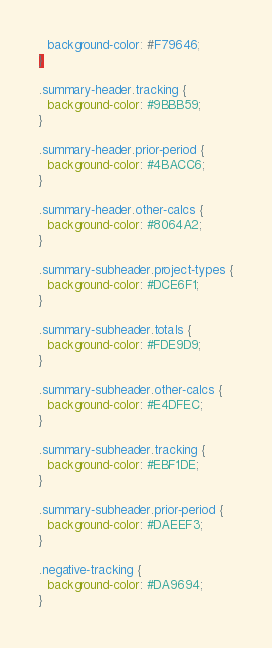<code> <loc_0><loc_0><loc_500><loc_500><_CSS_>  background-color: #F79646;
}

.summary-header.tracking {
  background-color: #9BBB59;
}

.summary-header.prior-period {
  background-color: #4BACC6;
}

.summary-header.other-calcs {
  background-color: #8064A2;
}

.summary-subheader.project-types {
  background-color: #DCE6F1;
}

.summary-subheader.totals {
  background-color: #FDE9D9;
}

.summary-subheader.other-calcs {
  background-color: #E4DFEC;
}

.summary-subheader.tracking {
  background-color: #EBF1DE;
}

.summary-subheader.prior-period {
  background-color: #DAEEF3;
}

.negative-tracking {
  background-color: #DA9694;
}</code> 